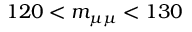<formula> <loc_0><loc_0><loc_500><loc_500>1 2 0 < { m _ { \mu \mu } } < 1 3 0</formula> 